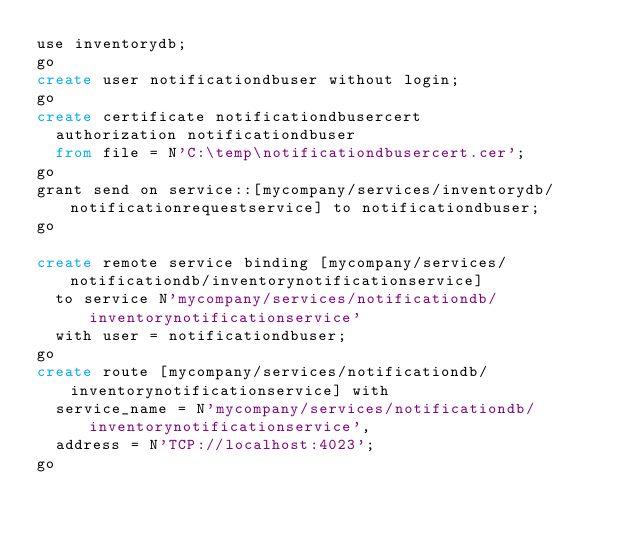Convert code to text. <code><loc_0><loc_0><loc_500><loc_500><_SQL_>use inventorydb;
go
create user notificationdbuser without login;
go
create certificate notificationdbusercert
  authorization notificationdbuser
  from file = N'C:\temp\notificationdbusercert.cer';
go
grant send on service::[mycompany/services/inventorydb/notificationrequestservice] to notificationdbuser;
go

create remote service binding [mycompany/services/notificationdb/inventorynotificationservice] 
  to service N'mycompany/services/notificationdb/inventorynotificationservice'
  with user = notificationdbuser;
go
create route [mycompany/services/notificationdb/inventorynotificationservice] with 
  service_name = N'mycompany/services/notificationdb/inventorynotificationservice',
  address = N'TCP://localhost:4023';
go</code> 